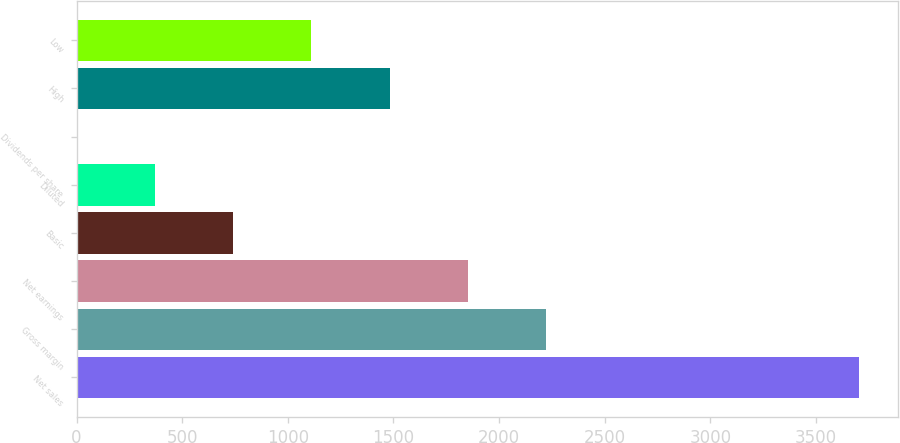Convert chart. <chart><loc_0><loc_0><loc_500><loc_500><bar_chart><fcel>Net sales<fcel>Gross margin<fcel>Net earnings<fcel>Basic<fcel>Diluted<fcel>Dividends per share<fcel>High<fcel>Low<nl><fcel>3703.4<fcel>2222.19<fcel>1851.89<fcel>740.99<fcel>370.69<fcel>0.39<fcel>1481.59<fcel>1111.29<nl></chart> 